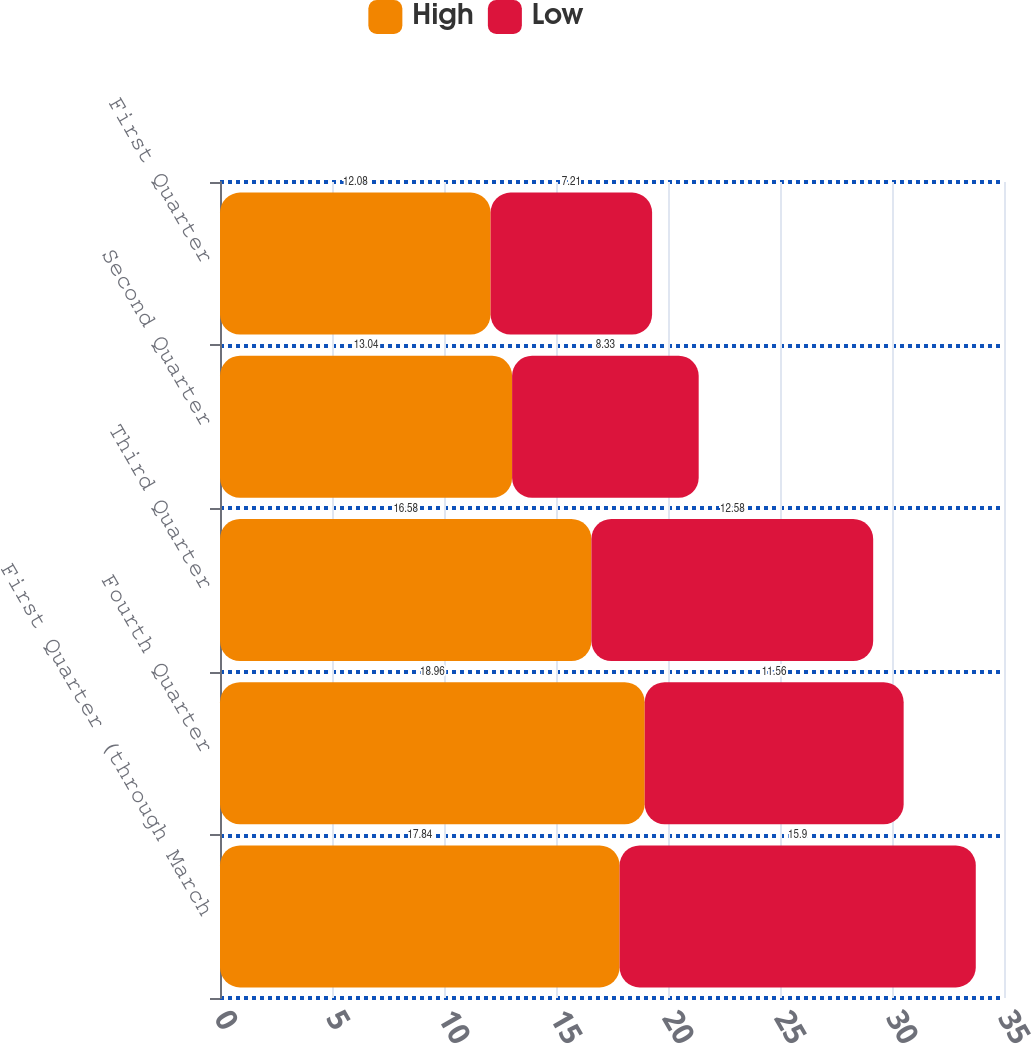Convert chart. <chart><loc_0><loc_0><loc_500><loc_500><stacked_bar_chart><ecel><fcel>First Quarter (through March<fcel>Fourth Quarter<fcel>Third Quarter<fcel>Second Quarter<fcel>First Quarter<nl><fcel>High<fcel>17.84<fcel>18.96<fcel>16.58<fcel>13.04<fcel>12.08<nl><fcel>Low<fcel>15.9<fcel>11.56<fcel>12.58<fcel>8.33<fcel>7.21<nl></chart> 